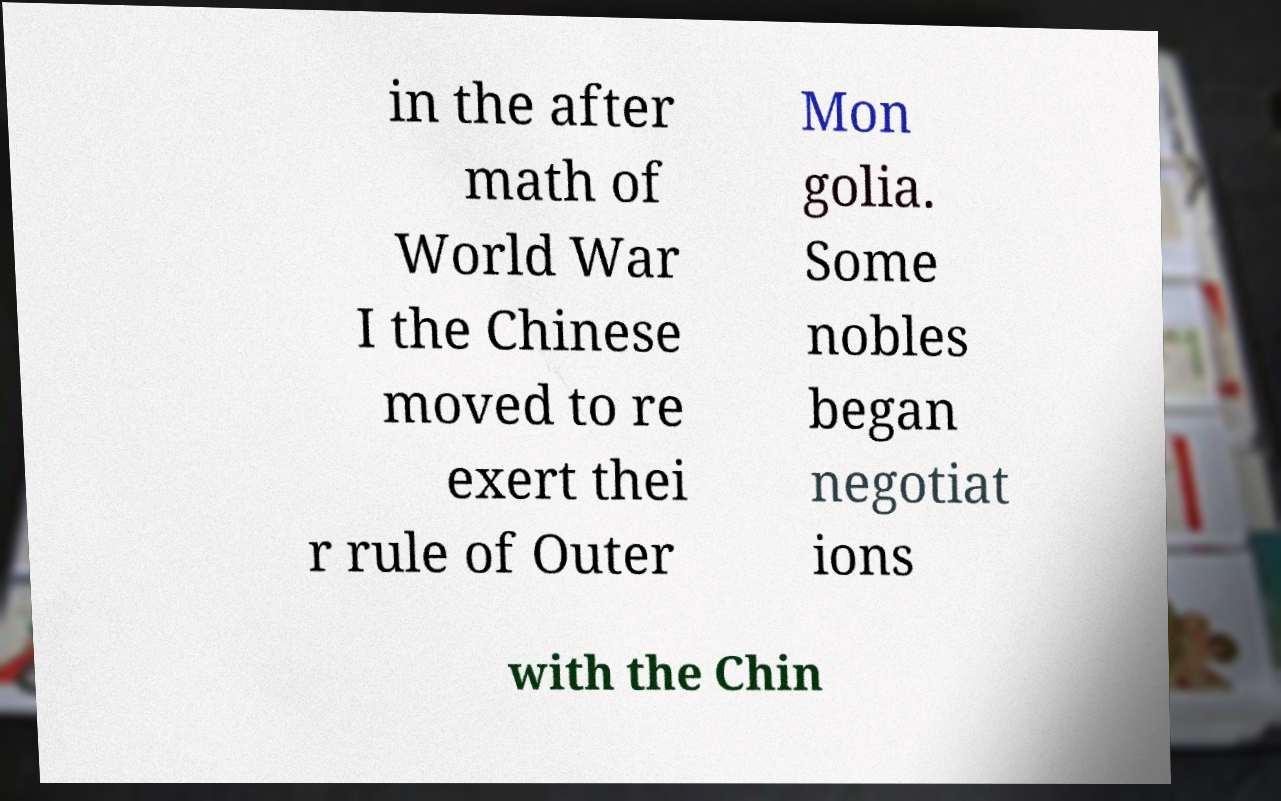Could you extract and type out the text from this image? in the after math of World War I the Chinese moved to re exert thei r rule of Outer Mon golia. Some nobles began negotiat ions with the Chin 